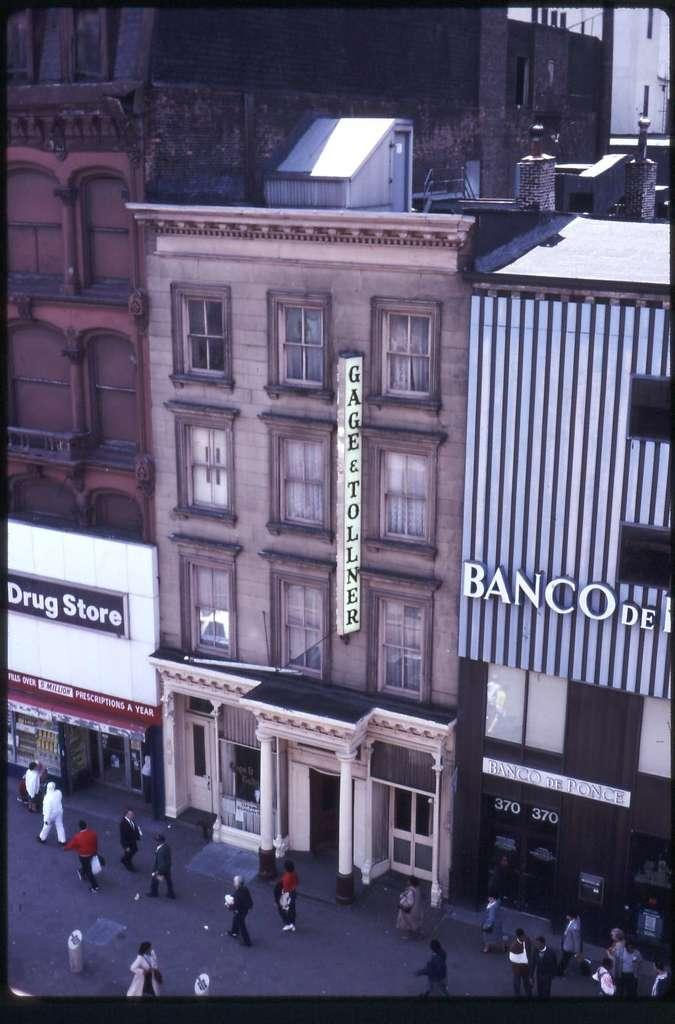What type of structures are visible in the image? There are buildings in the image. What might these buildings be used for? The buildings appear to be shopping stores. Are there any people in the image? Yes, there are people in front of the buildings. What type of suit is the sail wearing in the image? There is no sail or suit present in the image. What year is depicted in the image? The image does not depict a specific year; it is a photograph of a current scene. 